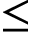Convert formula to latex. <formula><loc_0><loc_0><loc_500><loc_500>\leq</formula> 